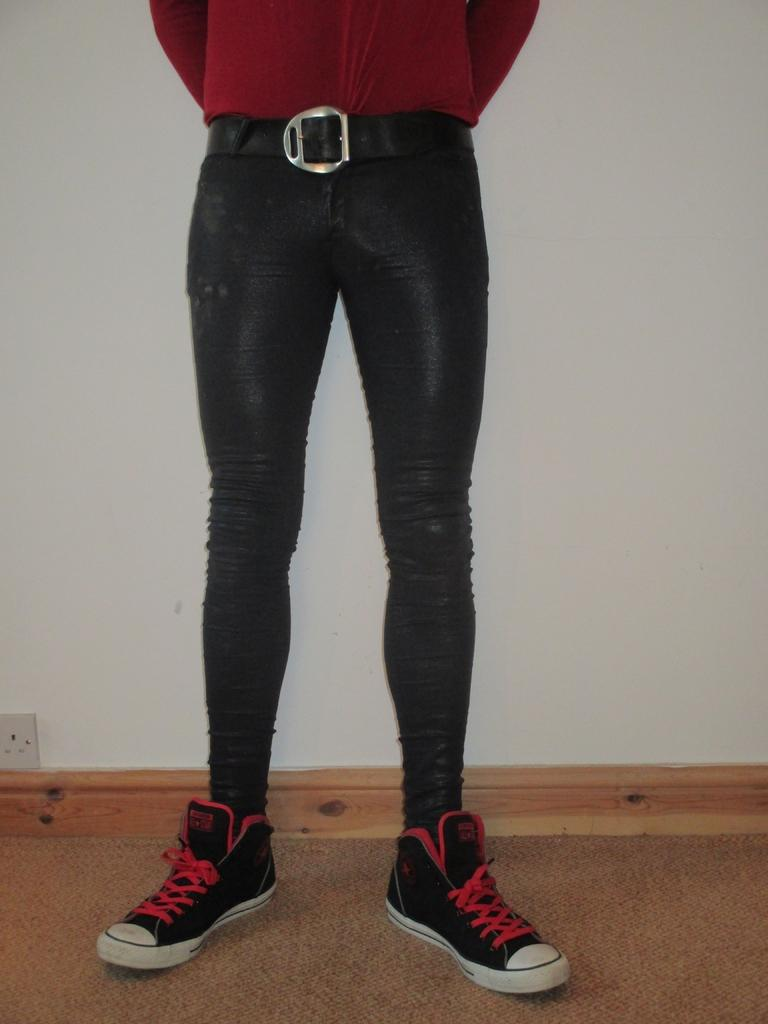What part of a person can be seen in the image? There are legs of a person visible in the image. What type of footwear is the person wearing? The person is wearing shoes. What can be seen in the background of the image? There is a wall in the background of the image. Where is the electric socket located in the image? The electric socket is on the left side of the image. What type of deer can be seen grazing in the plantation in the image? There is no deer or plantation present in the image. What kind of flower is growing near the person's legs in the image? There is no flower visible near the person's legs in the image. 